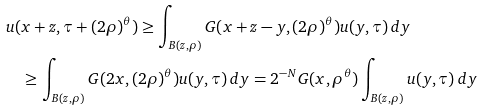Convert formula to latex. <formula><loc_0><loc_0><loc_500><loc_500>& u ( x + z , \tau + ( 2 \rho ) ^ { \theta } ) \geq \int _ { B ( z , \rho ) } G ( x + z - y , ( 2 \rho ) ^ { \theta } ) u ( y , \tau ) \, d y \\ & \quad \geq \int _ { B ( z , \rho ) } G ( 2 x , ( 2 \rho ) ^ { \theta } ) u ( y , \tau ) \, d y = 2 ^ { - N } G ( x , \rho ^ { \theta } ) \int _ { B ( z , \rho ) } u ( y , \tau ) \, d y</formula> 